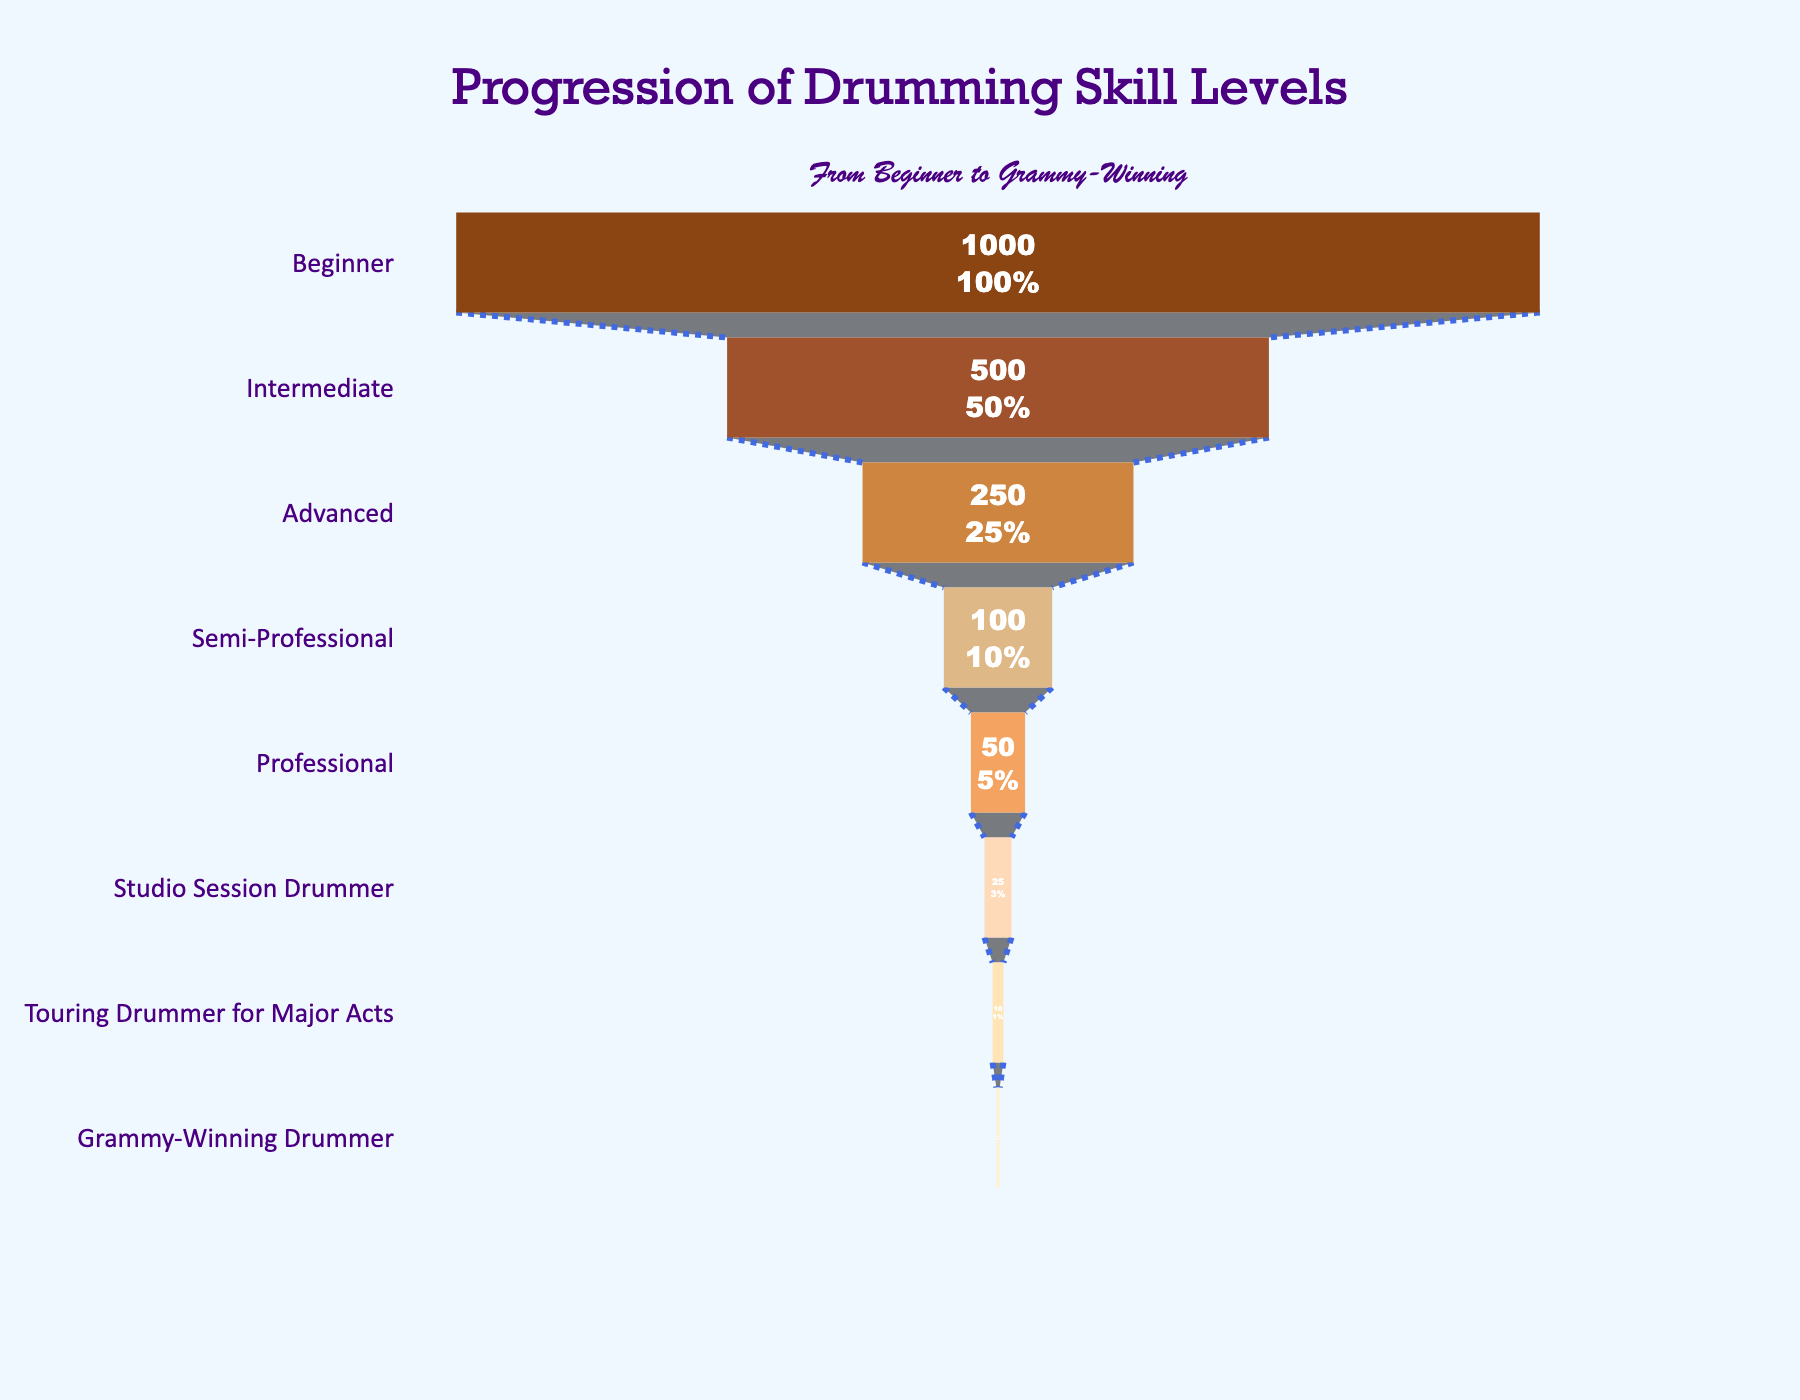what is the title of the figure? The title of the figure is generally located at the top and is usually in a larger font size compared to other text. For this figure, it appears that the title is "Progression of Drumming Skill Levels".
Answer: Progression of Drumming Skill Levels How many stages are represented in the funnel chart? By visually counting the number of distinct stages listed on the left side of the funnel chart, you can determine there are eight stages.
Answer: 8 Which stage has the highest number of drummers? The stage with the highest number of drummers is located at the widest part of the funnel chart. The chart shows that the "Beginner" stage has 1,000 drummers.
Answer: Beginner What percentage of drummers are at the semi-professional level relative to beginners? The funnel chart indicates specific values and the percentage of drummers at each stage compared to the initial number. For Semi-Professional with 100 drummers, the percentage relative to 1,000 beginners is 10%.
Answer: 10% Which stage has the fewest number of drummers? By checking the narrowest part of the funnel chart, you can see that the "Grammy-Winning Drummer" stage has the fewest drummers with 3.
Answer: Grammy-Winning Drummer Compare the number of drummers at the intermediate level to those at the advanced level. By looking at the values in the figure, there are 500 drummers at the intermediate level and 250 at the advanced level. So, the number of intermediate level drummers is double that of advanced level drummers.
Answer: Intermediate (500) > Advanced (250) Is the percentage decrease for each subsequent stage consistent throughout the chart? To determine if the percentage decrease is consistent, check the value at each stage and calculate the percentage drop from the previous stage. The differences are noticeable and varied across stages, indicating inconsistency.
Answer: No How many drummers progress from being semi-professionals to professionals? The data shows 100 drummers as Semi-Professionals and 50 as Professionals. By subtracting these, we find that 50 drummers proceed to the Professional level.
Answer: 50 What is the percentage of drummers who are Studio Session Drummers relative to Semi-Professional ones? Studio Session Drummers are 25, and Semi-Professional drummers are 100. To get the percentage, (25/100) * 100 = 25%.
Answer: 25% What stage has double the number of drummers than the Touring Drummer for Major Acts? Touring Drummer for Major Acts has 10 drummers. The stage with double that number (20 drummers) doesn't exist in the chart. However, the closest stage above would be "Studio Session Drummer" with 25 drummers.
Answer: No exact double. Closest is Studio Session Drummer What is the median number of drummers across all stages? To find the median, list the numbers: 1000, 500, 250, 100, 50, 25, 10, 3. The middle values are 100 and 50. Therefore, the median is (100 + 50)/2 = 75.
Answer: 75 